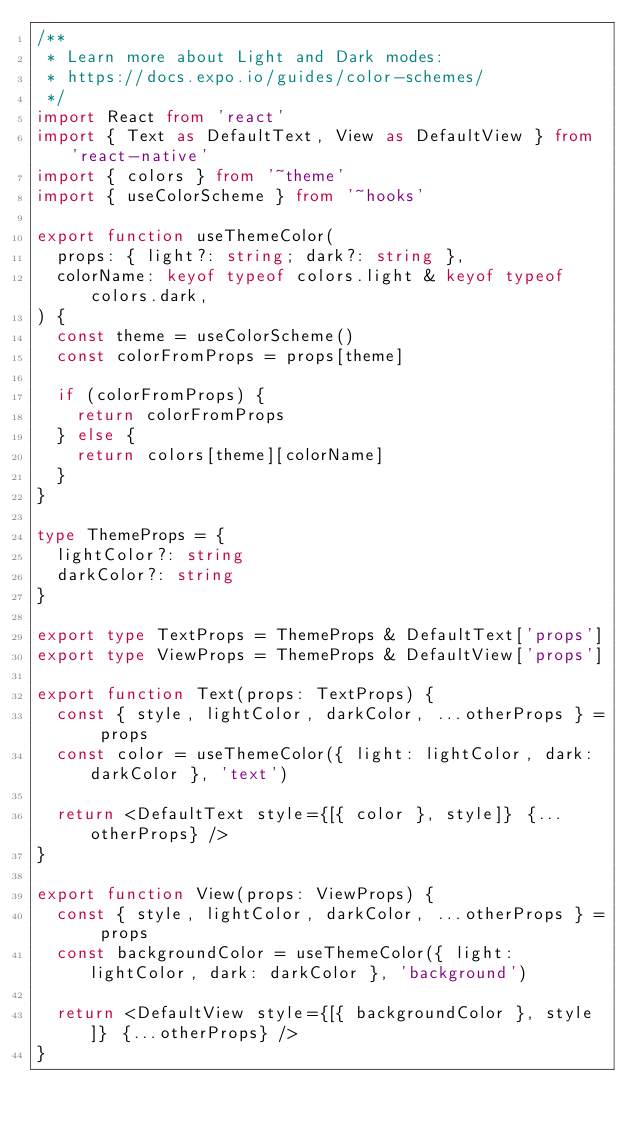Convert code to text. <code><loc_0><loc_0><loc_500><loc_500><_TypeScript_>/**
 * Learn more about Light and Dark modes:
 * https://docs.expo.io/guides/color-schemes/
 */
import React from 'react'
import { Text as DefaultText, View as DefaultView } from 'react-native'
import { colors } from '~theme'
import { useColorScheme } from '~hooks'

export function useThemeColor(
  props: { light?: string; dark?: string },
  colorName: keyof typeof colors.light & keyof typeof colors.dark,
) {
  const theme = useColorScheme()
  const colorFromProps = props[theme]

  if (colorFromProps) {
    return colorFromProps
  } else {
    return colors[theme][colorName]
  }
}

type ThemeProps = {
  lightColor?: string
  darkColor?: string
}

export type TextProps = ThemeProps & DefaultText['props']
export type ViewProps = ThemeProps & DefaultView['props']

export function Text(props: TextProps) {
  const { style, lightColor, darkColor, ...otherProps } = props
  const color = useThemeColor({ light: lightColor, dark: darkColor }, 'text')

  return <DefaultText style={[{ color }, style]} {...otherProps} />
}

export function View(props: ViewProps) {
  const { style, lightColor, darkColor, ...otherProps } = props
  const backgroundColor = useThemeColor({ light: lightColor, dark: darkColor }, 'background')

  return <DefaultView style={[{ backgroundColor }, style]} {...otherProps} />
}
</code> 